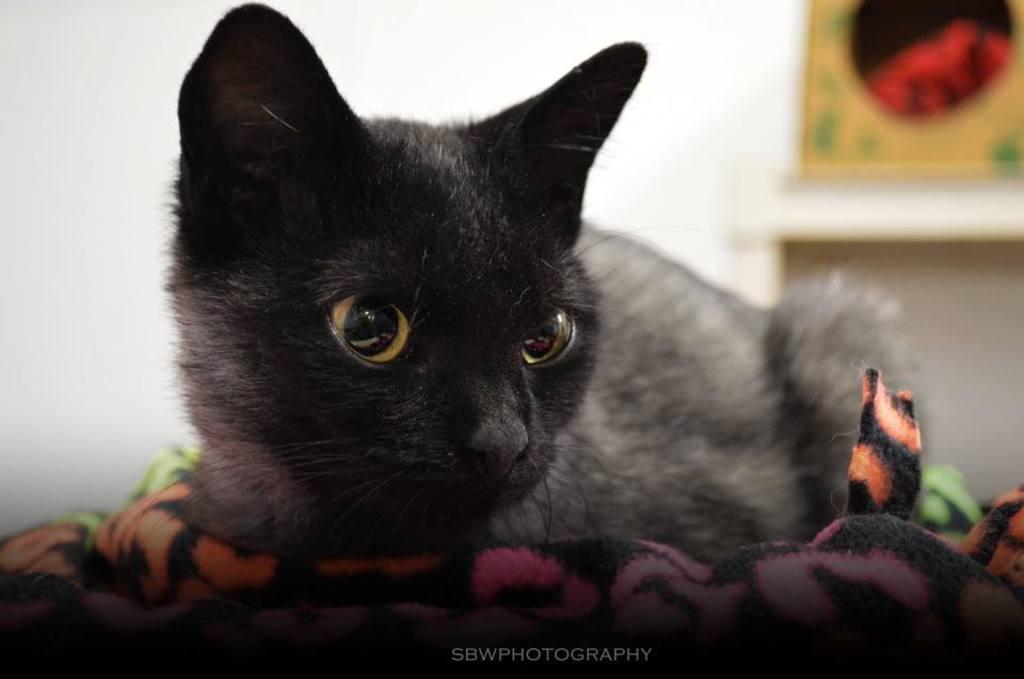Please provide a concise description of this image. In this image a black cat is sitting on the cloth. Behind it there is a wall having two frames attached to it. 